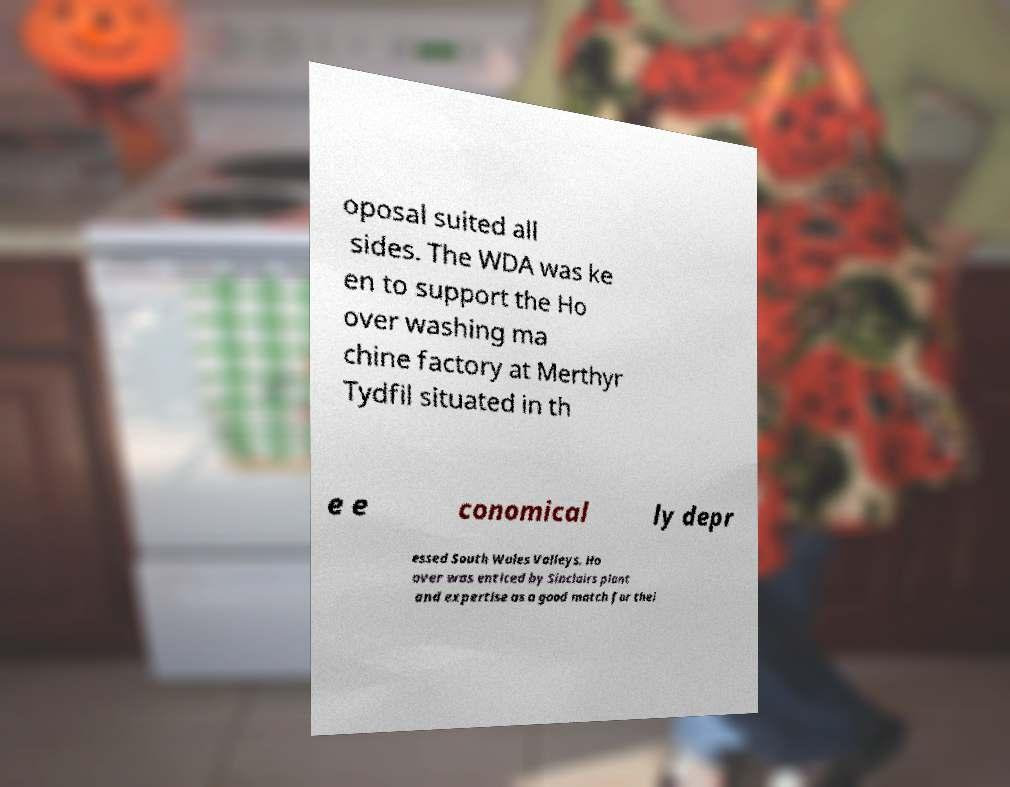I need the written content from this picture converted into text. Can you do that? oposal suited all sides. The WDA was ke en to support the Ho over washing ma chine factory at Merthyr Tydfil situated in th e e conomical ly depr essed South Wales Valleys. Ho over was enticed by Sinclairs plant and expertise as a good match for thei 